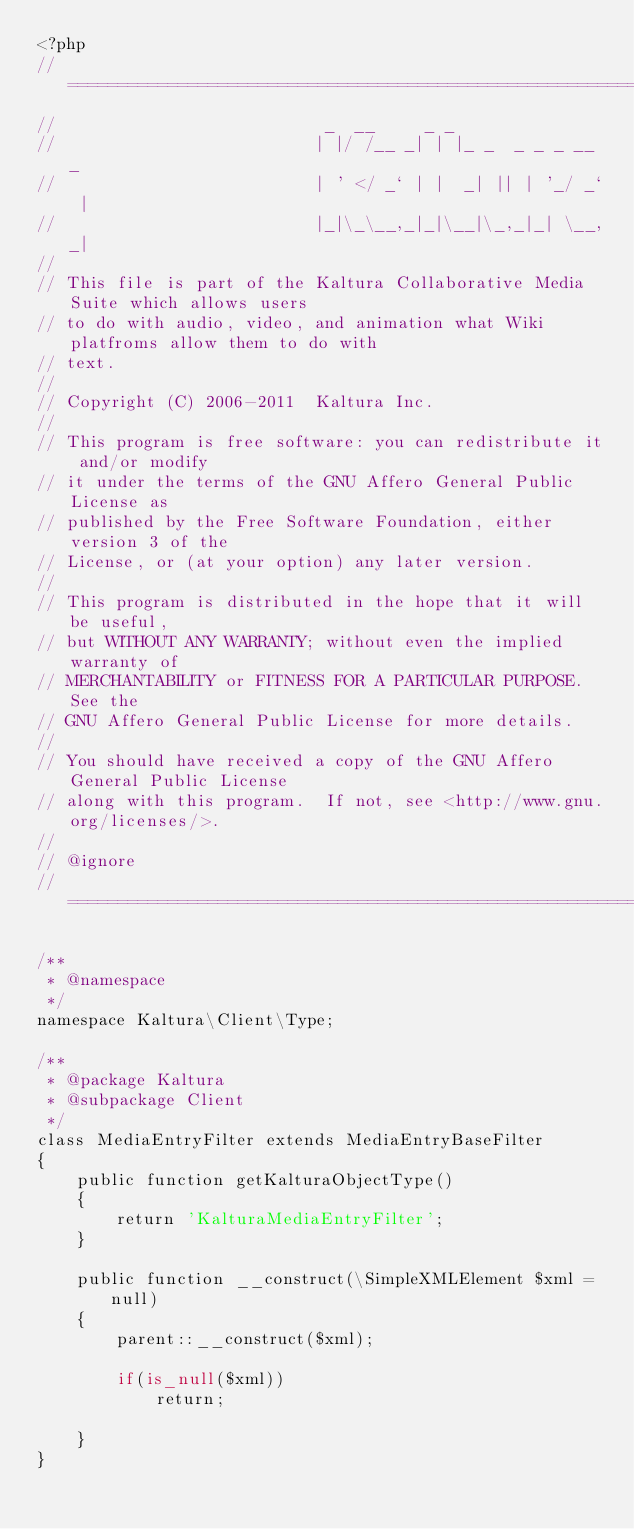<code> <loc_0><loc_0><loc_500><loc_500><_PHP_><?php
// ===================================================================================================
//                           _  __     _ _
//                          | |/ /__ _| | |_ _  _ _ _ __ _
//                          | ' </ _` | |  _| || | '_/ _` |
//                          |_|\_\__,_|_|\__|\_,_|_| \__,_|
//
// This file is part of the Kaltura Collaborative Media Suite which allows users
// to do with audio, video, and animation what Wiki platfroms allow them to do with
// text.
//
// Copyright (C) 2006-2011  Kaltura Inc.
//
// This program is free software: you can redistribute it and/or modify
// it under the terms of the GNU Affero General Public License as
// published by the Free Software Foundation, either version 3 of the
// License, or (at your option) any later version.
//
// This program is distributed in the hope that it will be useful,
// but WITHOUT ANY WARRANTY; without even the implied warranty of
// MERCHANTABILITY or FITNESS FOR A PARTICULAR PURPOSE.  See the
// GNU Affero General Public License for more details.
//
// You should have received a copy of the GNU Affero General Public License
// along with this program.  If not, see <http://www.gnu.org/licenses/>.
//
// @ignore
// ===================================================================================================

/**
 * @namespace
 */
namespace Kaltura\Client\Type;

/**
 * @package Kaltura
 * @subpackage Client
 */
class MediaEntryFilter extends MediaEntryBaseFilter
{
	public function getKalturaObjectType()
	{
		return 'KalturaMediaEntryFilter';
	}
	
	public function __construct(\SimpleXMLElement $xml = null)
	{
		parent::__construct($xml);
		
		if(is_null($xml))
			return;
		
	}
}
</code> 